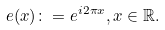<formula> <loc_0><loc_0><loc_500><loc_500>e ( x ) \colon = e ^ { i 2 \pi x } , x \in \mathbb { R } .</formula> 